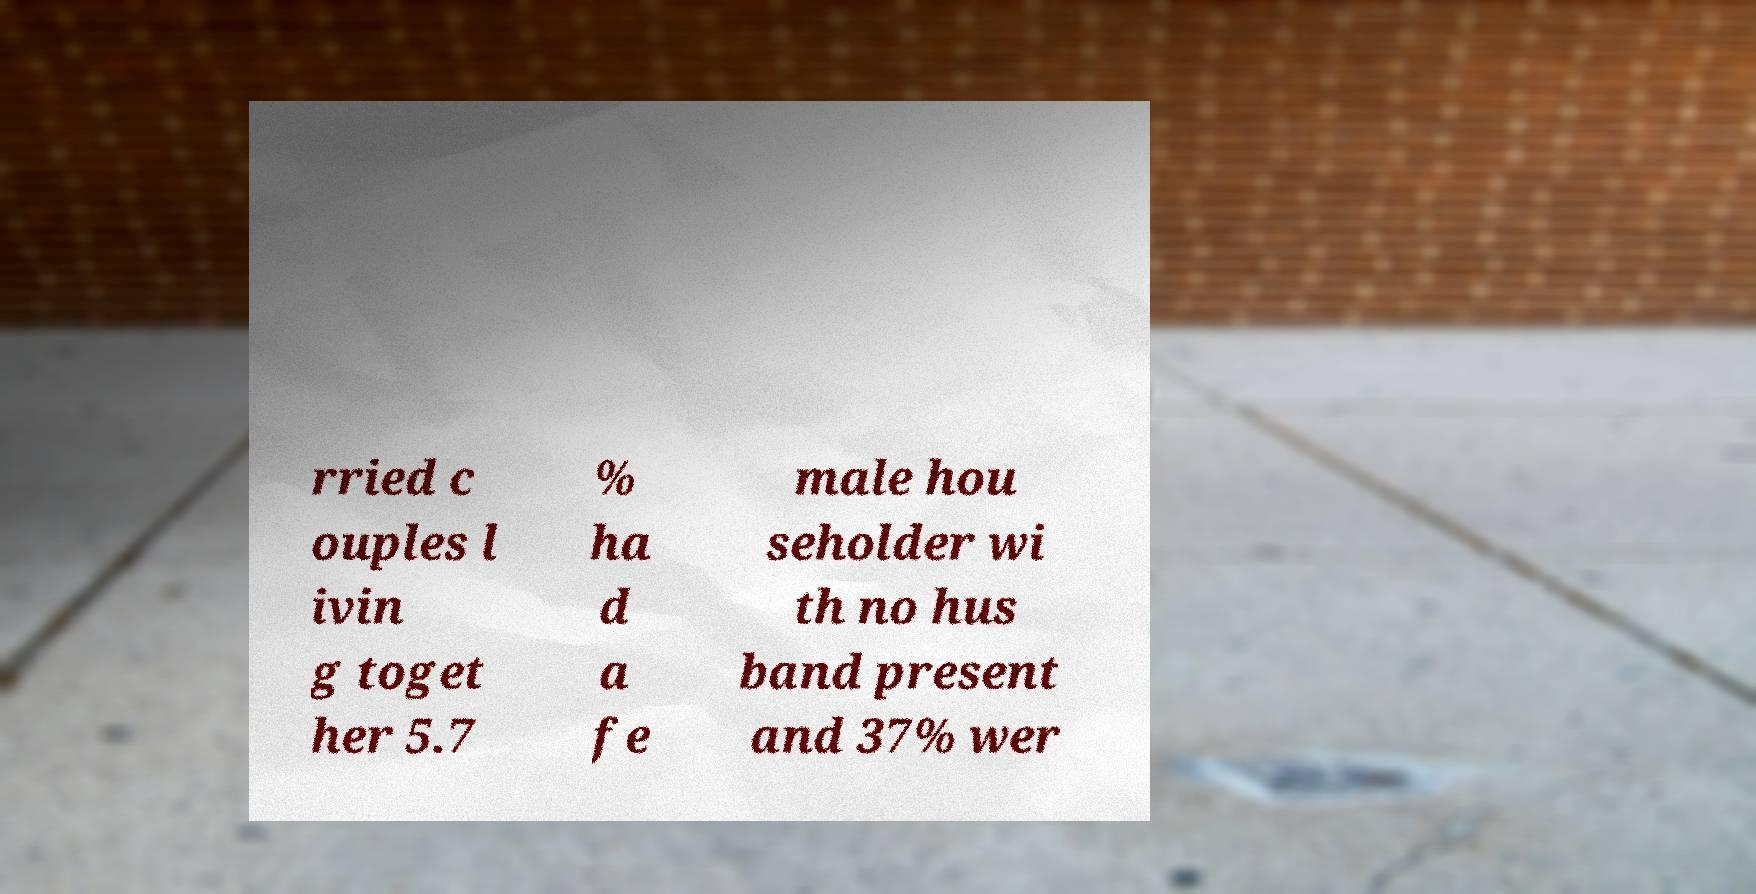For documentation purposes, I need the text within this image transcribed. Could you provide that? rried c ouples l ivin g toget her 5.7 % ha d a fe male hou seholder wi th no hus band present and 37% wer 